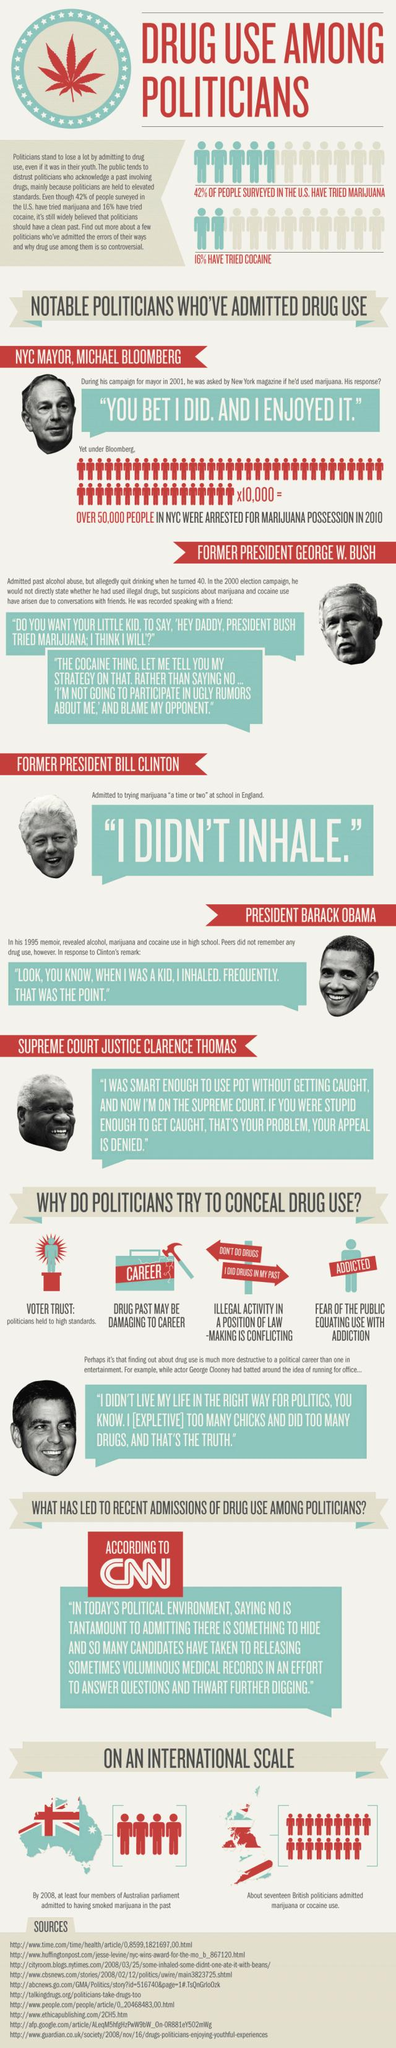Identify some key points in this picture. Among the pictures of famous personalities given, three of them were Presidents of the United States of America. The second reason why politicians try to hide their drug use is because a drug past can be damaging to their career. 